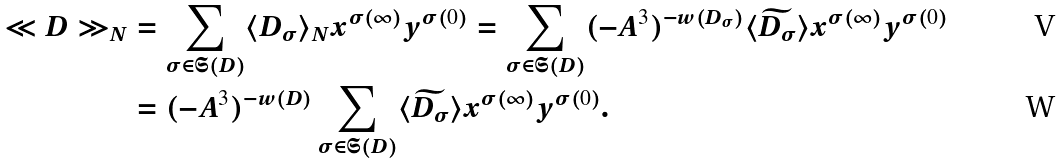<formula> <loc_0><loc_0><loc_500><loc_500>\ll D \gg _ { N } & = \sum _ { \sigma \in \mathfrak S ( D ) } \langle D _ { \sigma } \rangle _ { N } x ^ { \sigma ( \infty ) } y ^ { \sigma ( 0 ) } = \sum _ { \sigma \in \mathfrak S ( D ) } ( - A ^ { 3 } ) ^ { - w ( D _ { \sigma } ) } \langle \widetilde { D _ { \sigma } } \rangle x ^ { \sigma ( \infty ) } y ^ { \sigma ( 0 ) } \\ & = ( - A ^ { 3 } ) ^ { - w ( D ) } \sum _ { \sigma \in \mathfrak S ( D ) } \langle \widetilde { D _ { \sigma } } \rangle x ^ { \sigma ( \infty ) } y ^ { \sigma ( 0 ) } .</formula> 